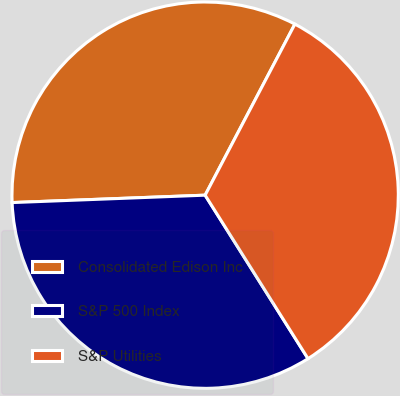Convert chart. <chart><loc_0><loc_0><loc_500><loc_500><pie_chart><fcel>Consolidated Edison Inc<fcel>S&P 500 Index<fcel>S&P Utilities<nl><fcel>33.3%<fcel>33.33%<fcel>33.37%<nl></chart> 